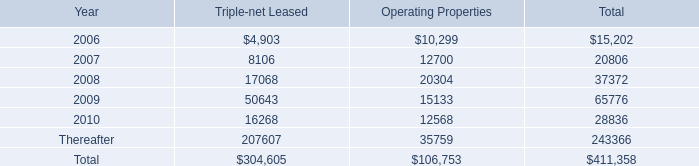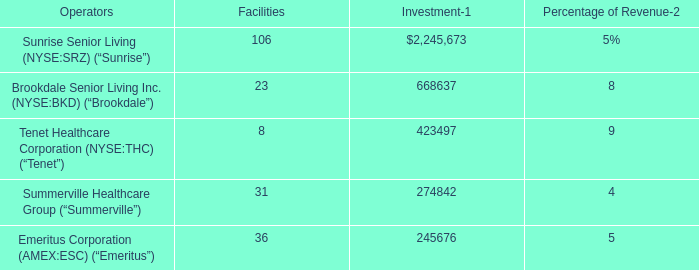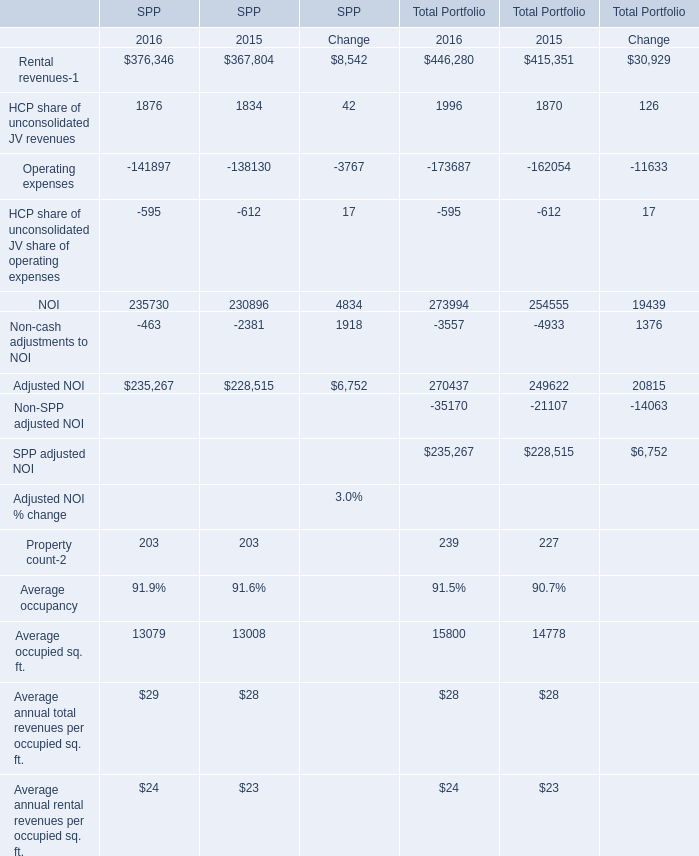What is the ratio of NOI to the total Amount in 2015 for SPP? 
Computations: (230896 / (((((((((367804 + 1834) - 138130) - 612) + 230896) - 2381) + 228515) + 203) + 28) + 23))
Answer: 0.33552. 